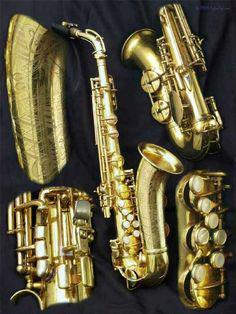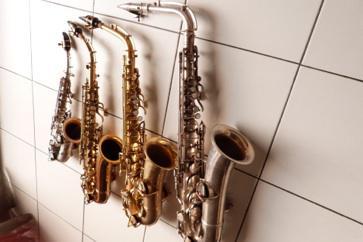The first image is the image on the left, the second image is the image on the right. Evaluate the accuracy of this statement regarding the images: "At least one image contains exactly three saxophones, and no image shows a saxophone broken down into parts.". Is it true? Answer yes or no. No. 